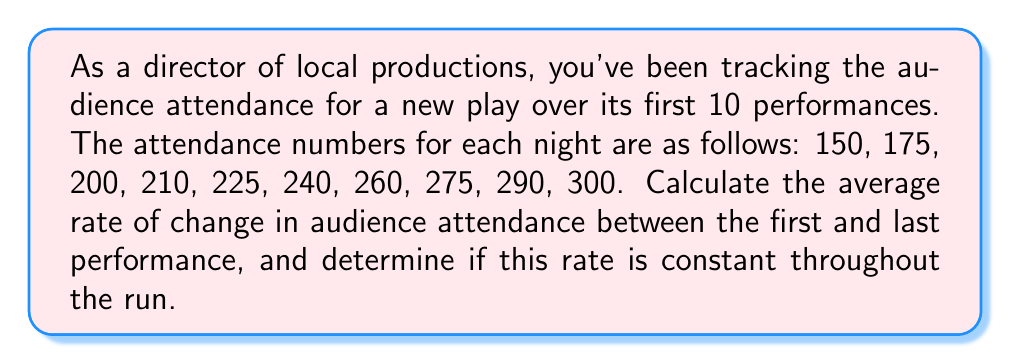What is the answer to this math problem? To solve this problem, we'll follow these steps:

1. Calculate the average rate of change between the first and last performance.
2. Examine the rate of change between consecutive performances to determine if it's constant.

Step 1: Average rate of change

The average rate of change is given by the formula:

$$\text{Average rate of change} = \frac{\text{Change in y}}{\text{Change in x}} = \frac{y_2 - y_1}{x_2 - x_1}$$

Where:
$y_1$ = attendance at the first performance (150)
$y_2$ = attendance at the last performance (300)
$x_1$ = first performance number (1)
$x_2$ = last performance number (10)

Plugging in the values:

$$\text{Average rate of change} = \frac{300 - 150}{10 - 1} = \frac{150}{9} \approx 16.67$$

Step 2: Examining the rate of change between consecutive performances

To determine if the rate is constant, we'll calculate the change between each consecutive performance:

1. 175 - 150 = 25
2. 200 - 175 = 25
3. 210 - 200 = 10
4. 225 - 210 = 15
5. 240 - 225 = 15
6. 260 - 240 = 20
7. 275 - 260 = 15
8. 290 - 275 = 15
9. 300 - 290 = 10

We can see that the change between consecutive performances is not constant. It varies between 10 and 25 audience members per performance.
Answer: The average rate of change in audience attendance between the first and last performance is approximately 16.67 audience members per performance. This rate is not constant throughout the run, as the change between consecutive performances varies between 10 and 25 audience members. 